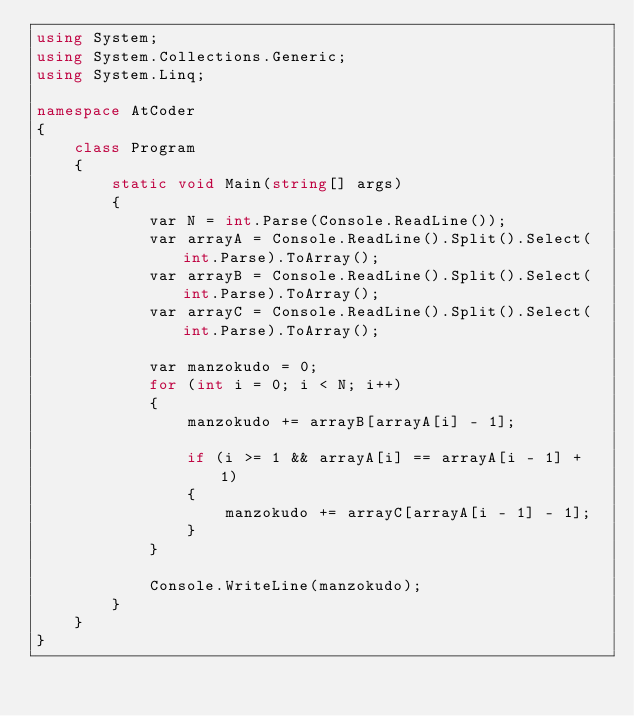Convert code to text. <code><loc_0><loc_0><loc_500><loc_500><_C#_>using System;
using System.Collections.Generic;
using System.Linq;

namespace AtCoder
{
    class Program
    {
        static void Main(string[] args)
        {
            var N = int.Parse(Console.ReadLine());
            var arrayA = Console.ReadLine().Split().Select(int.Parse).ToArray();
            var arrayB = Console.ReadLine().Split().Select(int.Parse).ToArray();
            var arrayC = Console.ReadLine().Split().Select(int.Parse).ToArray();

            var manzokudo = 0;
            for (int i = 0; i < N; i++)
            {
                manzokudo += arrayB[arrayA[i] - 1];

                if (i >= 1 && arrayA[i] == arrayA[i - 1] + 1)
                {
                    manzokudo += arrayC[arrayA[i - 1] - 1];
                }
            }

            Console.WriteLine(manzokudo);
        }
    }
}
</code> 